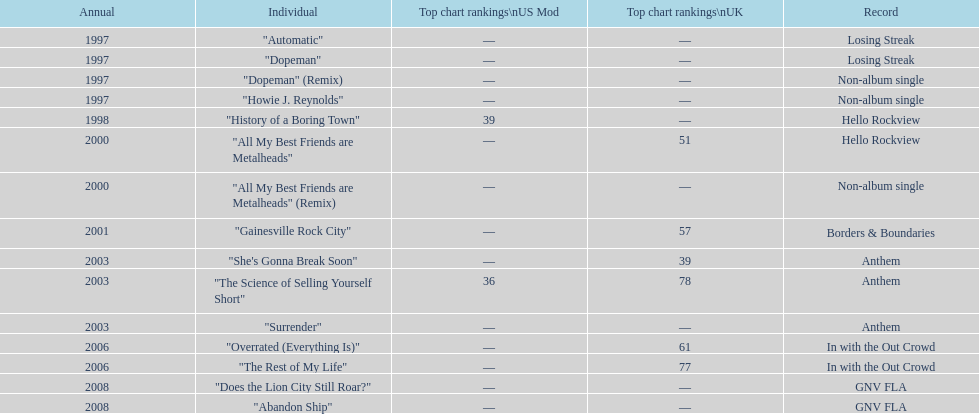Which single was released before "dopeman"? "Automatic". 